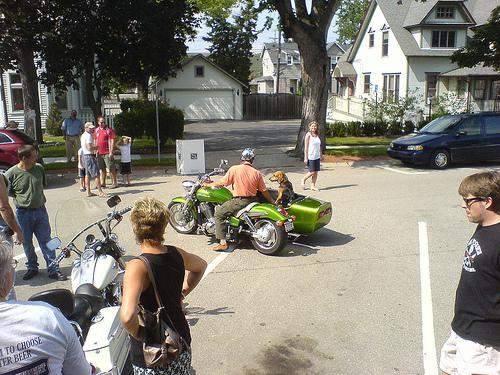Question: how many people are in the street?
Choices:
A. Seven.
B. Three.
C. One.
D. Eleven.
Answer with the letter. Answer: D Question: what are the people looking at?
Choices:
A. A movie poster.
B. A tray of donuts.
C. A motorcycle.
D. A street performer.
Answer with the letter. Answer: C Question: when was the picture taken?
Choices:
A. At night.
B. At daytime.
C. In the morning.
D. At sunset.
Answer with the letter. Answer: B Question: who is standing in front of the tree?
Choices:
A. A woman.
B. A man.
C. A child.
D. A boy.
Answer with the letter. Answer: A Question: what is in the sidecar?
Choices:
A. A suitcase.
B. A woman.
C. A dog.
D. A mannequin.
Answer with the letter. Answer: C 